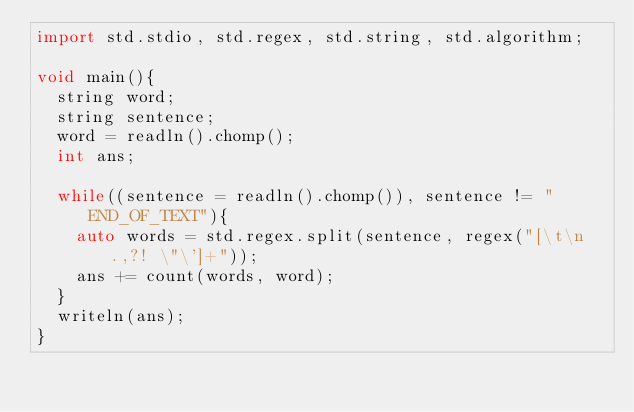<code> <loc_0><loc_0><loc_500><loc_500><_D_>import std.stdio, std.regex, std.string, std.algorithm;

void main(){
	string word;
	string sentence;
	word = readln().chomp();
	int ans;

	while((sentence = readln().chomp()), sentence != "END_OF_TEXT"){
		auto words = std.regex.split(sentence, regex("[\t\n.,?! \"\']+"));
		ans += count(words, word);
	}
	writeln(ans);
}</code> 